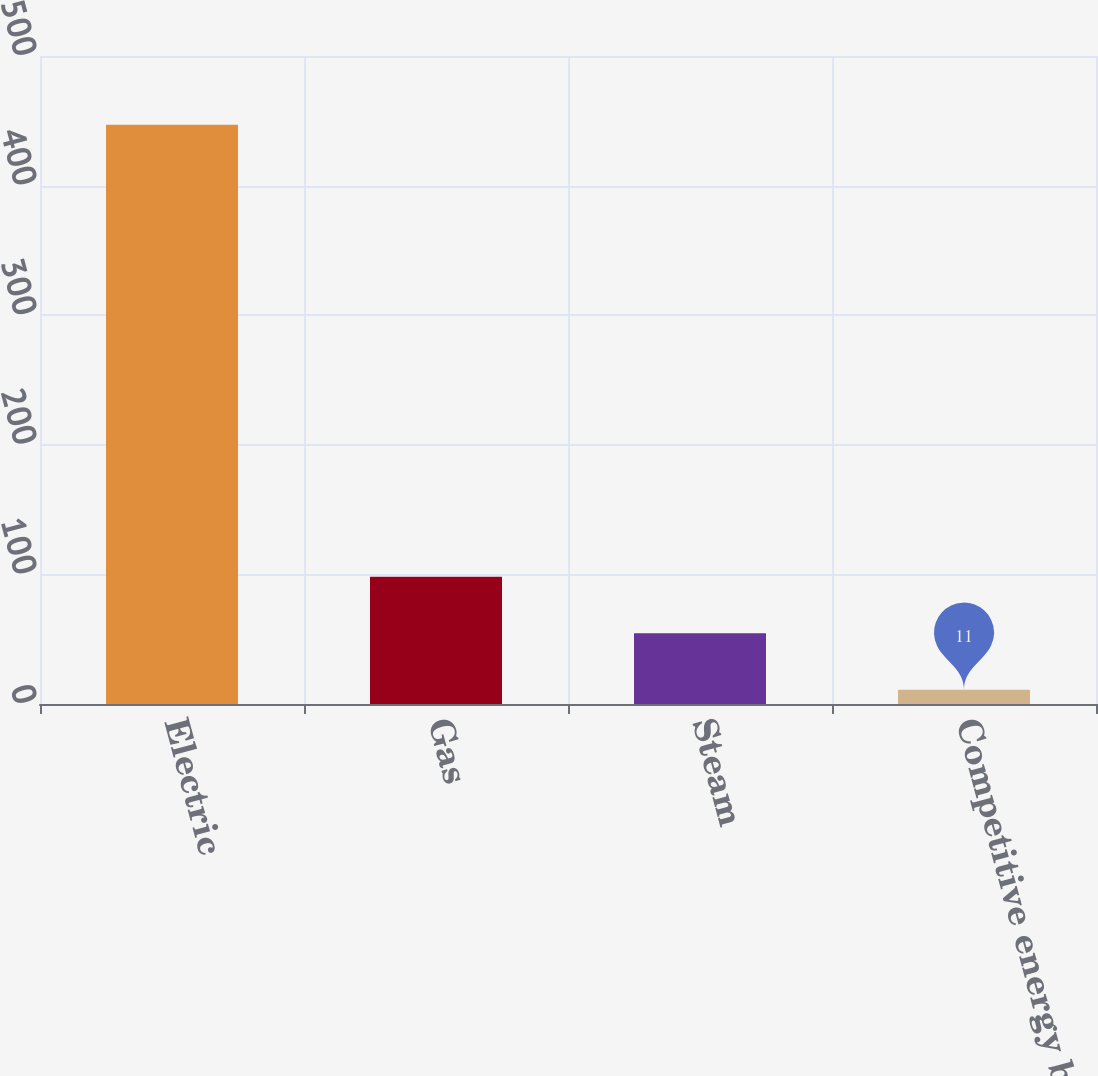Convert chart. <chart><loc_0><loc_0><loc_500><loc_500><bar_chart><fcel>Electric<fcel>Gas<fcel>Steam<fcel>Competitive energy businesses<nl><fcel>447<fcel>98.2<fcel>54.6<fcel>11<nl></chart> 